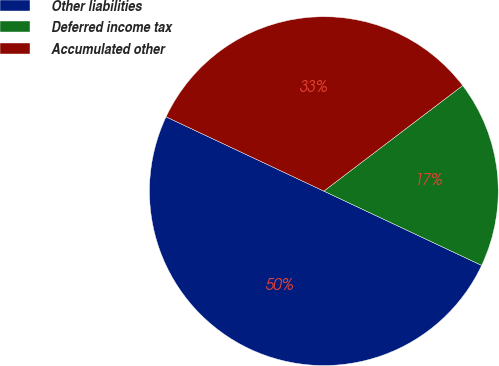<chart> <loc_0><loc_0><loc_500><loc_500><pie_chart><fcel>Other liabilities<fcel>Deferred income tax<fcel>Accumulated other<nl><fcel>50.0%<fcel>17.35%<fcel>32.65%<nl></chart> 